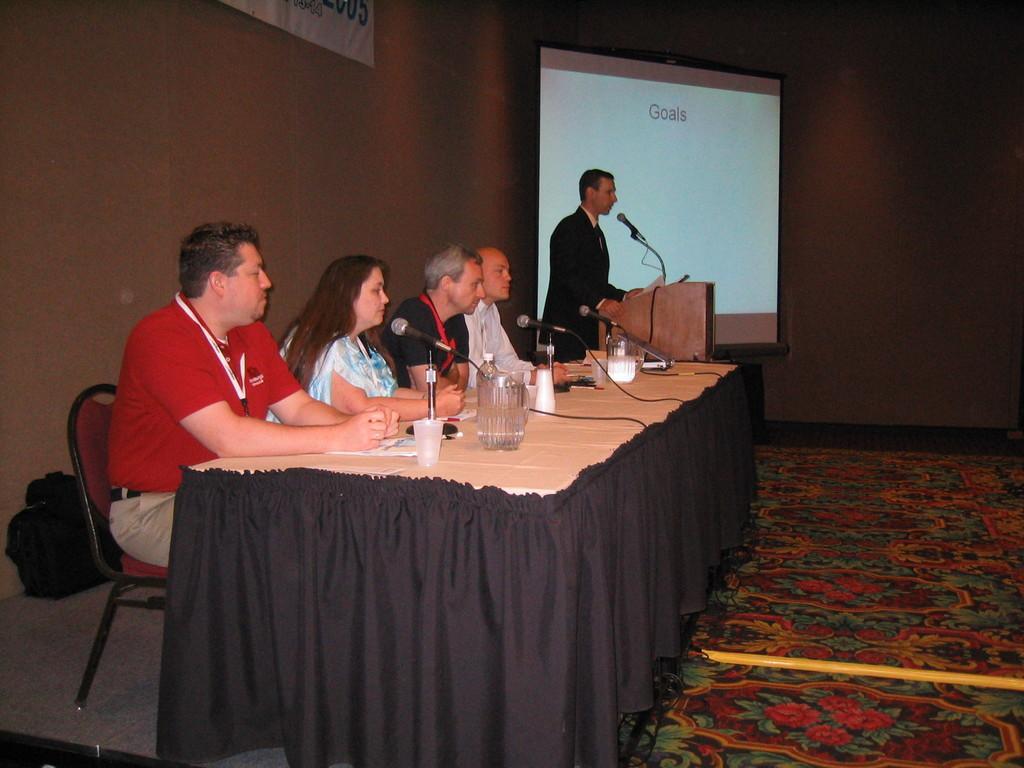In one or two sentences, can you explain what this image depicts? On the left side there are few persons sitting on the chairs at the table and on the table we can see water bottles, papers, microphones, glasses and other objects. In the background we can see a banner on the wall, screen and a man is standing at the podium and there is a microphone and papers on the podium. On the left side there is a bag on the floor and on the right side there is a pole on the carpet on the floor. 